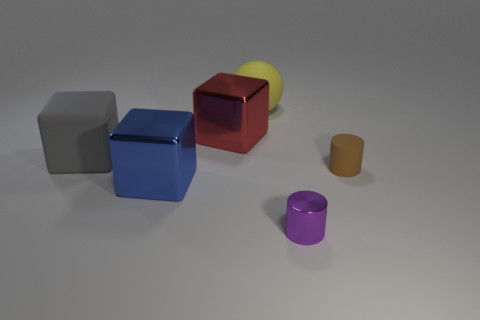Add 3 big red blocks. How many objects exist? 9 Subtract all cylinders. How many objects are left? 4 Subtract all small purple objects. Subtract all large red shiny blocks. How many objects are left? 4 Add 1 brown cylinders. How many brown cylinders are left? 2 Add 4 cylinders. How many cylinders exist? 6 Subtract 0 cyan balls. How many objects are left? 6 